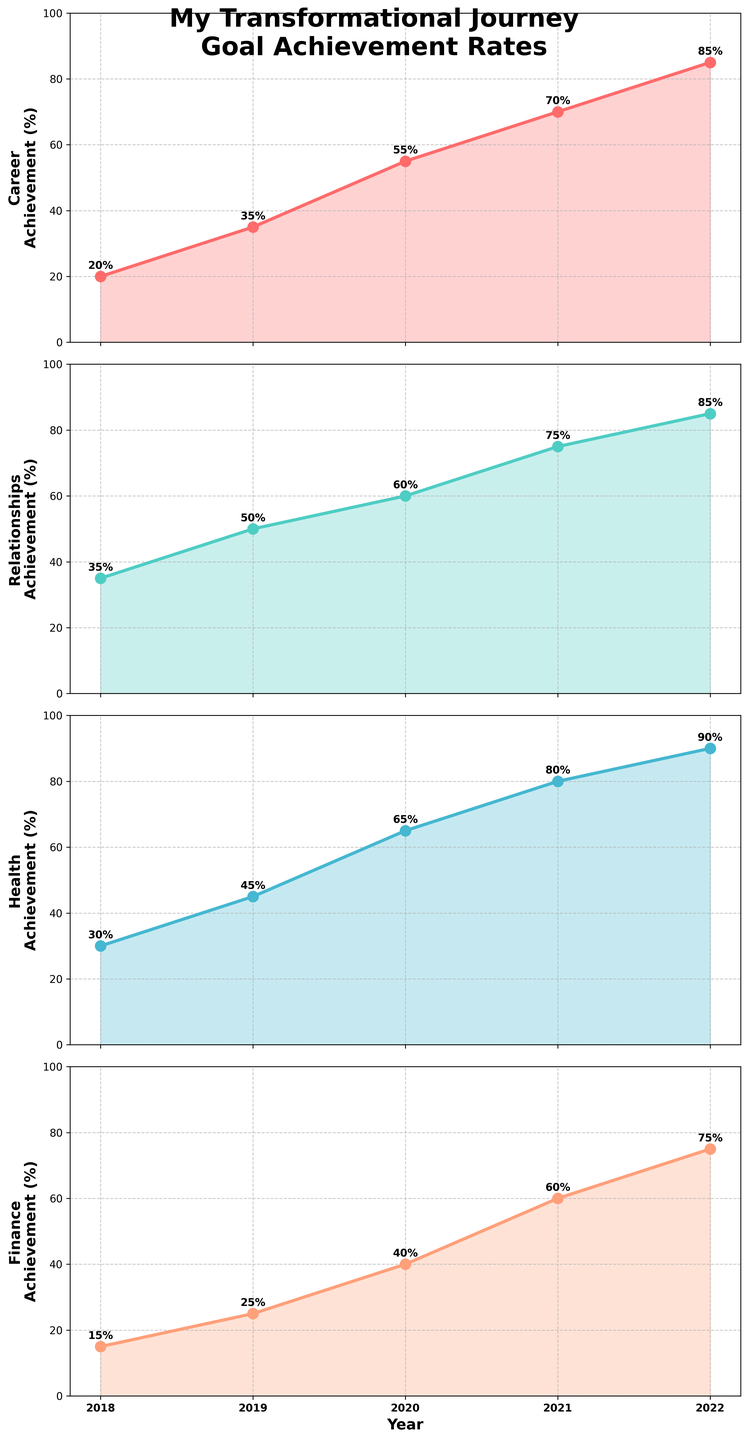What's the title of the figure? The figure's title is displayed at the top in bold, which summarizes the content.
Answer: My Transformational Journey\nGoal Achievement Rates How many categories are being tracked in the figure? By looking at the subplots, we can see that there are four categories.
Answer: Four (Career, Relationships, Health, Finance) What is the goal achievement rate for Health in 2020? The Health subplot shows a line graph, and for the year 2020, the corresponding value on the y-axis is annotated.
Answer: 65% Which category saw the highest goal achievement rate in 2022? By examining the 2022 data points in all subplots, we can see which value is the highest.
Answer: Health What's the sum of the goal achievement rates for Career and Finance in 2019? From the Career subplot, the 2019 value is 35%, and from Finance, it is 25%. Adding these two gives the sum.
Answer: 60% How many years are covered in the data? The x-axis labels display the years from start to end, which we can count.
Answer: Five years (2018 to 2022) How did the goal achievement rate for Relationships change from 2018 to 2019? Checking the Relationships subplot, the 2018 value is 35% and 2019 value is 50%. Calculating the difference: 50% - 35% = 15%.
Answer: Increased by 15% Which year saw the steepest increase in goal achievement rate for Career? By checking the Career subplot slopes between consecutive years, the steepest rise can be identified visually or by numerical difference.
Answer: 2020 (20% increase) What was the minimum achievement rate for Finance and in which year did it occur? Observing the Finance subplot for the lowest value and its corresponding year.
Answer: 15% in 2018 Which category had the most consistent increase in goal achievement rates over the years? By comparing the trends in all subplots, the category showing the smoothest, steady increase without fluctuation can be identified.
Answer: Relationships 